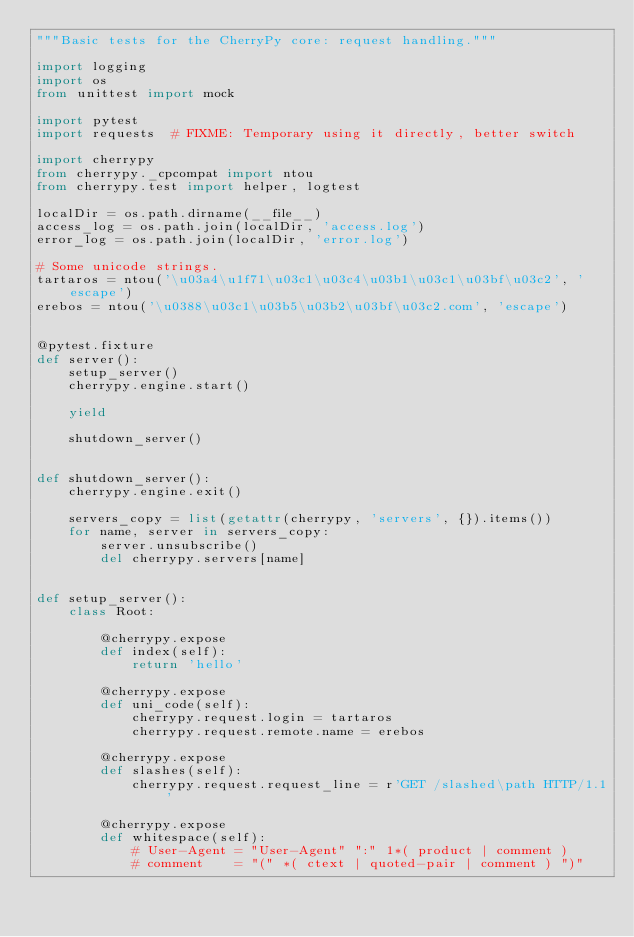<code> <loc_0><loc_0><loc_500><loc_500><_Python_>"""Basic tests for the CherryPy core: request handling."""

import logging
import os
from unittest import mock

import pytest
import requests  # FIXME: Temporary using it directly, better switch

import cherrypy
from cherrypy._cpcompat import ntou
from cherrypy.test import helper, logtest

localDir = os.path.dirname(__file__)
access_log = os.path.join(localDir, 'access.log')
error_log = os.path.join(localDir, 'error.log')

# Some unicode strings.
tartaros = ntou('\u03a4\u1f71\u03c1\u03c4\u03b1\u03c1\u03bf\u03c2', 'escape')
erebos = ntou('\u0388\u03c1\u03b5\u03b2\u03bf\u03c2.com', 'escape')


@pytest.fixture
def server():
    setup_server()
    cherrypy.engine.start()

    yield

    shutdown_server()


def shutdown_server():
    cherrypy.engine.exit()

    servers_copy = list(getattr(cherrypy, 'servers', {}).items())
    for name, server in servers_copy:
        server.unsubscribe()
        del cherrypy.servers[name]


def setup_server():
    class Root:

        @cherrypy.expose
        def index(self):
            return 'hello'

        @cherrypy.expose
        def uni_code(self):
            cherrypy.request.login = tartaros
            cherrypy.request.remote.name = erebos

        @cherrypy.expose
        def slashes(self):
            cherrypy.request.request_line = r'GET /slashed\path HTTP/1.1'

        @cherrypy.expose
        def whitespace(self):
            # User-Agent = "User-Agent" ":" 1*( product | comment )
            # comment    = "(" *( ctext | quoted-pair | comment ) ")"</code> 